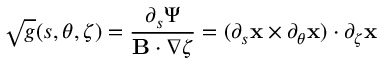Convert formula to latex. <formula><loc_0><loc_0><loc_500><loc_500>\sqrt { g } ( s , \theta , \zeta ) = \frac { \partial _ { s } \Psi } { B \cdot \nabla \zeta } = ( \partial _ { s } x \times \partial _ { \theta } x ) \cdot \partial _ { \zeta } x</formula> 